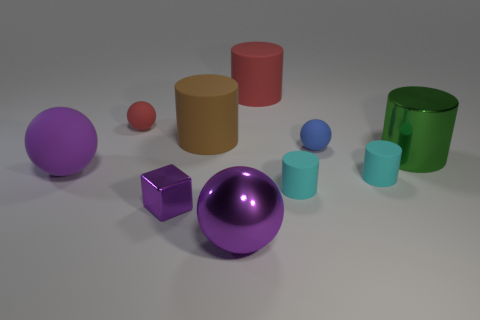What number of big brown rubber things are there?
Provide a short and direct response. 1. Does the big shiny object that is in front of the large purple rubber ball have the same color as the small rubber ball that is right of the tiny red sphere?
Make the answer very short. No. What is the size of the metal sphere that is the same color as the cube?
Ensure brevity in your answer.  Large. How many other things are there of the same size as the purple metallic ball?
Make the answer very short. 4. The tiny matte cylinder that is right of the blue sphere is what color?
Offer a very short reply. Cyan. Is the material of the purple thing that is right of the big brown object the same as the small red thing?
Your answer should be very brief. No. What number of big objects are both to the left of the blue sphere and to the right of the tiny purple object?
Your answer should be very brief. 3. The big rubber cylinder that is in front of the tiny thing behind the small matte sphere that is in front of the small red thing is what color?
Make the answer very short. Brown. What number of other things are there of the same shape as the brown thing?
Provide a short and direct response. 4. There is a big rubber object in front of the large brown rubber object; is there a purple metal cube behind it?
Give a very brief answer. No. 